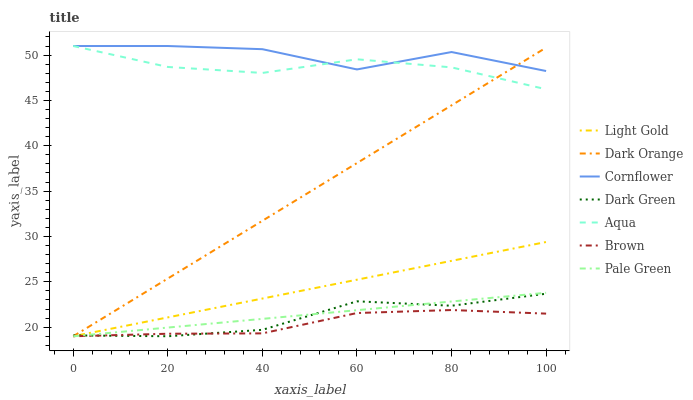Does Brown have the minimum area under the curve?
Answer yes or no. Yes. Does Cornflower have the maximum area under the curve?
Answer yes or no. Yes. Does Aqua have the minimum area under the curve?
Answer yes or no. No. Does Aqua have the maximum area under the curve?
Answer yes or no. No. Is Light Gold the smoothest?
Answer yes or no. Yes. Is Cornflower the roughest?
Answer yes or no. Yes. Is Brown the smoothest?
Answer yes or no. No. Is Brown the roughest?
Answer yes or no. No. Does Dark Orange have the lowest value?
Answer yes or no. Yes. Does Aqua have the lowest value?
Answer yes or no. No. Does Cornflower have the highest value?
Answer yes or no. Yes. Does Brown have the highest value?
Answer yes or no. No. Is Dark Green less than Cornflower?
Answer yes or no. Yes. Is Aqua greater than Dark Green?
Answer yes or no. Yes. Does Light Gold intersect Dark Green?
Answer yes or no. Yes. Is Light Gold less than Dark Green?
Answer yes or no. No. Is Light Gold greater than Dark Green?
Answer yes or no. No. Does Dark Green intersect Cornflower?
Answer yes or no. No. 